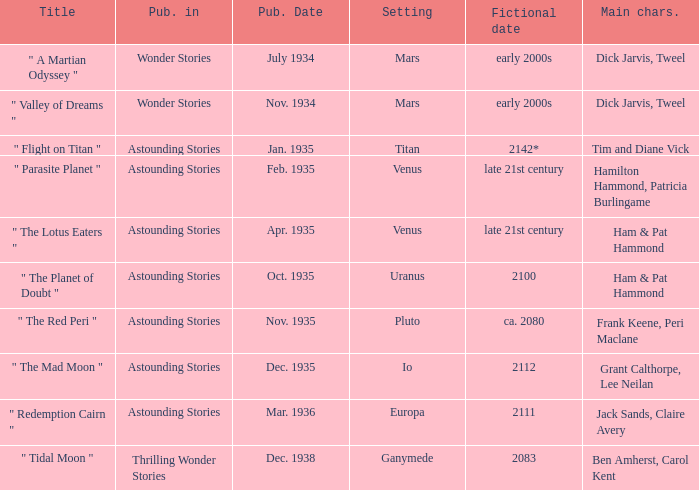Name the publication date when the fictional date is 2112 Dec. 1935. 